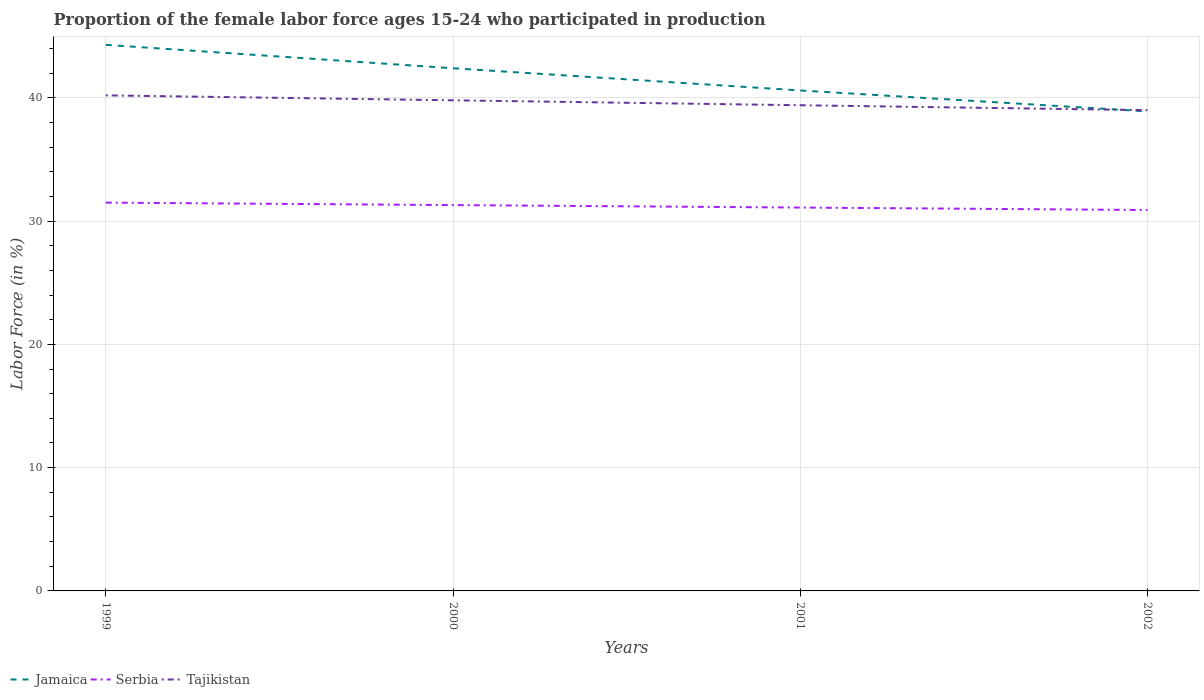Does the line corresponding to Serbia intersect with the line corresponding to Jamaica?
Offer a terse response. No. Is the number of lines equal to the number of legend labels?
Ensure brevity in your answer.  Yes. What is the total proportion of the female labor force who participated in production in Tajikistan in the graph?
Your answer should be very brief. 0.8. What is the difference between the highest and the second highest proportion of the female labor force who participated in production in Jamaica?
Offer a terse response. 5.4. Is the proportion of the female labor force who participated in production in Tajikistan strictly greater than the proportion of the female labor force who participated in production in Jamaica over the years?
Make the answer very short. No. How many lines are there?
Your answer should be compact. 3. How many years are there in the graph?
Provide a succinct answer. 4. Does the graph contain grids?
Provide a short and direct response. Yes. How many legend labels are there?
Provide a short and direct response. 3. How are the legend labels stacked?
Give a very brief answer. Horizontal. What is the title of the graph?
Offer a very short reply. Proportion of the female labor force ages 15-24 who participated in production. What is the label or title of the Y-axis?
Ensure brevity in your answer.  Labor Force (in %). What is the Labor Force (in %) of Jamaica in 1999?
Offer a terse response. 44.3. What is the Labor Force (in %) of Serbia in 1999?
Provide a short and direct response. 31.5. What is the Labor Force (in %) in Tajikistan in 1999?
Your answer should be very brief. 40.2. What is the Labor Force (in %) in Jamaica in 2000?
Your answer should be compact. 42.4. What is the Labor Force (in %) of Serbia in 2000?
Your response must be concise. 31.3. What is the Labor Force (in %) in Tajikistan in 2000?
Provide a short and direct response. 39.8. What is the Labor Force (in %) of Jamaica in 2001?
Offer a very short reply. 40.6. What is the Labor Force (in %) of Serbia in 2001?
Make the answer very short. 31.1. What is the Labor Force (in %) of Tajikistan in 2001?
Give a very brief answer. 39.4. What is the Labor Force (in %) in Jamaica in 2002?
Keep it short and to the point. 38.9. What is the Labor Force (in %) in Serbia in 2002?
Give a very brief answer. 30.9. What is the Labor Force (in %) in Tajikistan in 2002?
Offer a very short reply. 39. Across all years, what is the maximum Labor Force (in %) in Jamaica?
Give a very brief answer. 44.3. Across all years, what is the maximum Labor Force (in %) of Serbia?
Offer a very short reply. 31.5. Across all years, what is the maximum Labor Force (in %) of Tajikistan?
Keep it short and to the point. 40.2. Across all years, what is the minimum Labor Force (in %) in Jamaica?
Your answer should be very brief. 38.9. Across all years, what is the minimum Labor Force (in %) in Serbia?
Offer a terse response. 30.9. What is the total Labor Force (in %) in Jamaica in the graph?
Ensure brevity in your answer.  166.2. What is the total Labor Force (in %) of Serbia in the graph?
Make the answer very short. 124.8. What is the total Labor Force (in %) in Tajikistan in the graph?
Give a very brief answer. 158.4. What is the difference between the Labor Force (in %) in Jamaica in 1999 and that in 2000?
Your answer should be very brief. 1.9. What is the difference between the Labor Force (in %) in Tajikistan in 1999 and that in 2000?
Keep it short and to the point. 0.4. What is the difference between the Labor Force (in %) in Serbia in 1999 and that in 2001?
Keep it short and to the point. 0.4. What is the difference between the Labor Force (in %) of Tajikistan in 1999 and that in 2001?
Give a very brief answer. 0.8. What is the difference between the Labor Force (in %) in Jamaica in 1999 and that in 2002?
Give a very brief answer. 5.4. What is the difference between the Labor Force (in %) in Serbia in 2000 and that in 2002?
Offer a very short reply. 0.4. What is the difference between the Labor Force (in %) in Tajikistan in 2000 and that in 2002?
Provide a short and direct response. 0.8. What is the difference between the Labor Force (in %) in Jamaica in 2001 and that in 2002?
Your response must be concise. 1.7. What is the difference between the Labor Force (in %) in Serbia in 2001 and that in 2002?
Offer a terse response. 0.2. What is the difference between the Labor Force (in %) in Tajikistan in 2001 and that in 2002?
Ensure brevity in your answer.  0.4. What is the difference between the Labor Force (in %) of Jamaica in 1999 and the Labor Force (in %) of Serbia in 2000?
Offer a very short reply. 13. What is the difference between the Labor Force (in %) of Serbia in 1999 and the Labor Force (in %) of Tajikistan in 2001?
Keep it short and to the point. -7.9. What is the difference between the Labor Force (in %) of Jamaica in 1999 and the Labor Force (in %) of Serbia in 2002?
Offer a very short reply. 13.4. What is the difference between the Labor Force (in %) in Jamaica in 2000 and the Labor Force (in %) in Serbia in 2001?
Your answer should be compact. 11.3. What is the difference between the Labor Force (in %) in Jamaica in 2000 and the Labor Force (in %) in Tajikistan in 2002?
Keep it short and to the point. 3.4. What is the difference between the Labor Force (in %) of Serbia in 2000 and the Labor Force (in %) of Tajikistan in 2002?
Offer a terse response. -7.7. What is the difference between the Labor Force (in %) in Jamaica in 2001 and the Labor Force (in %) in Serbia in 2002?
Give a very brief answer. 9.7. What is the difference between the Labor Force (in %) in Serbia in 2001 and the Labor Force (in %) in Tajikistan in 2002?
Make the answer very short. -7.9. What is the average Labor Force (in %) in Jamaica per year?
Your answer should be compact. 41.55. What is the average Labor Force (in %) in Serbia per year?
Keep it short and to the point. 31.2. What is the average Labor Force (in %) of Tajikistan per year?
Offer a very short reply. 39.6. In the year 1999, what is the difference between the Labor Force (in %) in Jamaica and Labor Force (in %) in Serbia?
Your response must be concise. 12.8. In the year 1999, what is the difference between the Labor Force (in %) of Jamaica and Labor Force (in %) of Tajikistan?
Offer a very short reply. 4.1. In the year 1999, what is the difference between the Labor Force (in %) of Serbia and Labor Force (in %) of Tajikistan?
Your response must be concise. -8.7. In the year 2000, what is the difference between the Labor Force (in %) of Jamaica and Labor Force (in %) of Tajikistan?
Ensure brevity in your answer.  2.6. In the year 2000, what is the difference between the Labor Force (in %) in Serbia and Labor Force (in %) in Tajikistan?
Give a very brief answer. -8.5. In the year 2001, what is the difference between the Labor Force (in %) of Jamaica and Labor Force (in %) of Serbia?
Your response must be concise. 9.5. In the year 2002, what is the difference between the Labor Force (in %) of Jamaica and Labor Force (in %) of Serbia?
Provide a succinct answer. 8. What is the ratio of the Labor Force (in %) of Jamaica in 1999 to that in 2000?
Give a very brief answer. 1.04. What is the ratio of the Labor Force (in %) of Serbia in 1999 to that in 2000?
Offer a very short reply. 1.01. What is the ratio of the Labor Force (in %) in Tajikistan in 1999 to that in 2000?
Make the answer very short. 1.01. What is the ratio of the Labor Force (in %) in Jamaica in 1999 to that in 2001?
Give a very brief answer. 1.09. What is the ratio of the Labor Force (in %) of Serbia in 1999 to that in 2001?
Provide a succinct answer. 1.01. What is the ratio of the Labor Force (in %) in Tajikistan in 1999 to that in 2001?
Your answer should be compact. 1.02. What is the ratio of the Labor Force (in %) of Jamaica in 1999 to that in 2002?
Make the answer very short. 1.14. What is the ratio of the Labor Force (in %) in Serbia in 1999 to that in 2002?
Provide a succinct answer. 1.02. What is the ratio of the Labor Force (in %) in Tajikistan in 1999 to that in 2002?
Offer a very short reply. 1.03. What is the ratio of the Labor Force (in %) of Jamaica in 2000 to that in 2001?
Keep it short and to the point. 1.04. What is the ratio of the Labor Force (in %) of Serbia in 2000 to that in 2001?
Provide a short and direct response. 1.01. What is the ratio of the Labor Force (in %) of Tajikistan in 2000 to that in 2001?
Offer a terse response. 1.01. What is the ratio of the Labor Force (in %) of Jamaica in 2000 to that in 2002?
Your response must be concise. 1.09. What is the ratio of the Labor Force (in %) in Serbia in 2000 to that in 2002?
Provide a succinct answer. 1.01. What is the ratio of the Labor Force (in %) of Tajikistan in 2000 to that in 2002?
Offer a terse response. 1.02. What is the ratio of the Labor Force (in %) of Jamaica in 2001 to that in 2002?
Give a very brief answer. 1.04. What is the ratio of the Labor Force (in %) in Serbia in 2001 to that in 2002?
Provide a short and direct response. 1.01. What is the ratio of the Labor Force (in %) in Tajikistan in 2001 to that in 2002?
Your response must be concise. 1.01. What is the difference between the highest and the second highest Labor Force (in %) in Jamaica?
Offer a very short reply. 1.9. What is the difference between the highest and the second highest Labor Force (in %) in Tajikistan?
Offer a very short reply. 0.4. What is the difference between the highest and the lowest Labor Force (in %) in Jamaica?
Your response must be concise. 5.4. What is the difference between the highest and the lowest Labor Force (in %) of Tajikistan?
Offer a terse response. 1.2. 